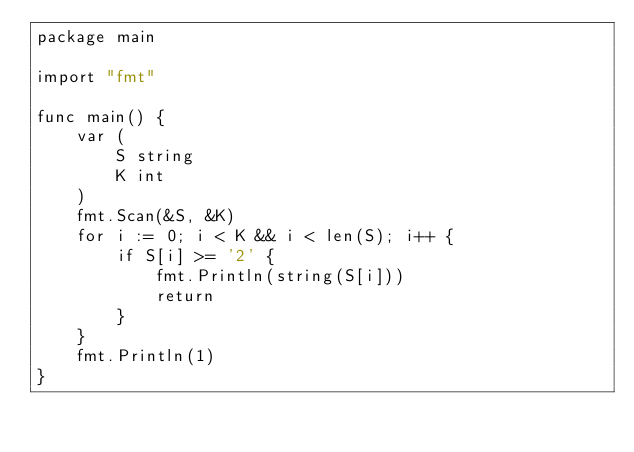Convert code to text. <code><loc_0><loc_0><loc_500><loc_500><_Go_>package main

import "fmt"

func main() {
	var (
		S string
		K int
	)
	fmt.Scan(&S, &K)
	for i := 0; i < K && i < len(S); i++ {
		if S[i] >= '2' {
			fmt.Println(string(S[i]))
			return
		}
	}
	fmt.Println(1)
}
</code> 